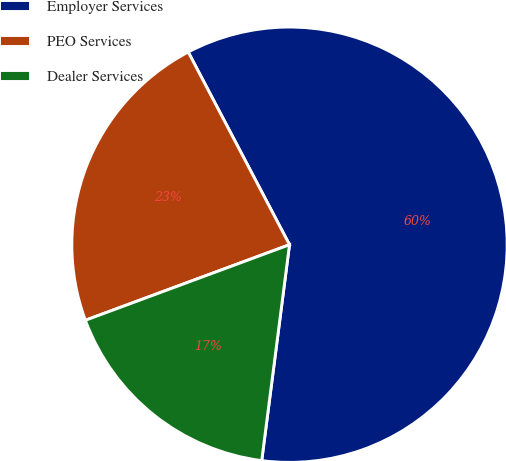<chart> <loc_0><loc_0><loc_500><loc_500><pie_chart><fcel>Employer Services<fcel>PEO Services<fcel>Dealer Services<nl><fcel>59.74%<fcel>22.94%<fcel>17.32%<nl></chart> 